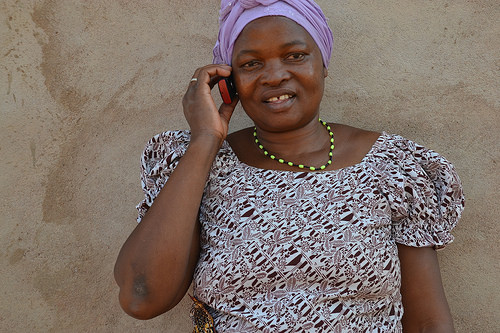<image>
Can you confirm if the cell is in the woman? No. The cell is not contained within the woman. These objects have a different spatial relationship. 